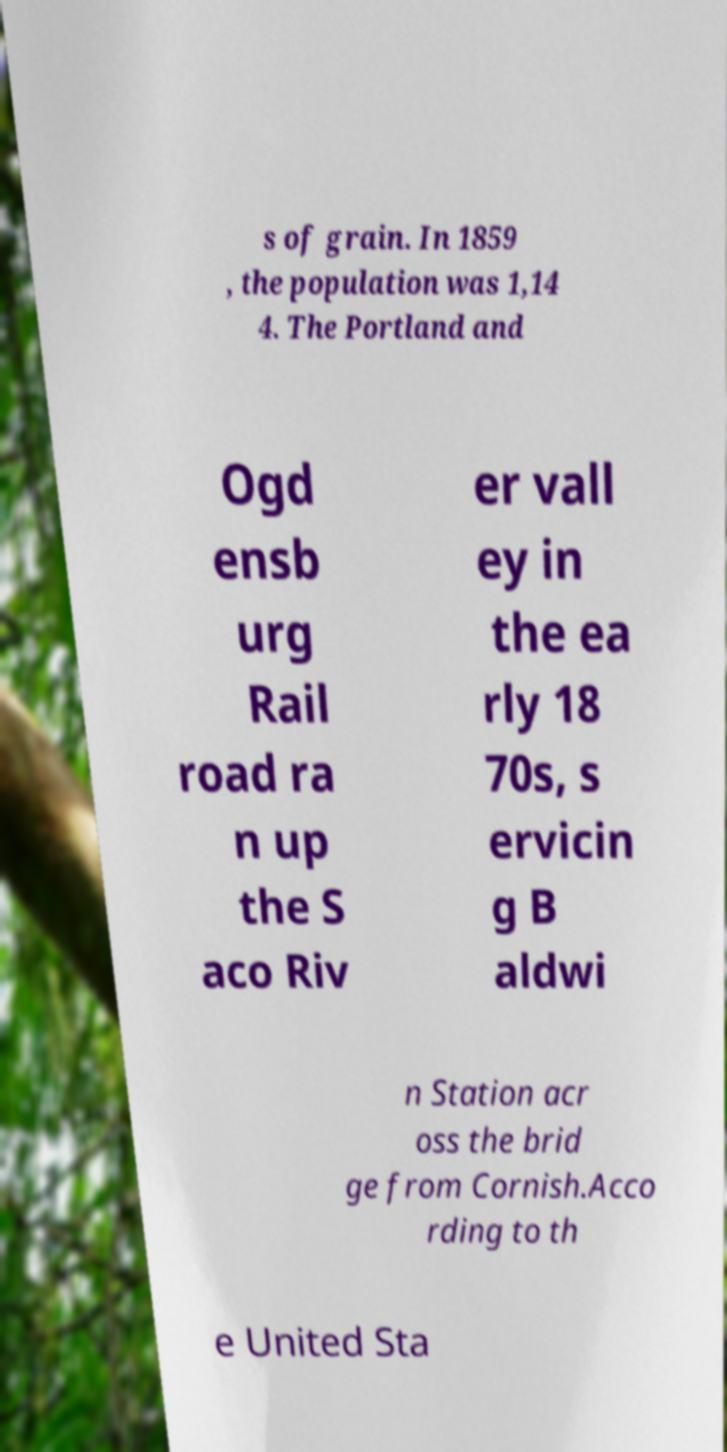For documentation purposes, I need the text within this image transcribed. Could you provide that? s of grain. In 1859 , the population was 1,14 4. The Portland and Ogd ensb urg Rail road ra n up the S aco Riv er vall ey in the ea rly 18 70s, s ervicin g B aldwi n Station acr oss the brid ge from Cornish.Acco rding to th e United Sta 